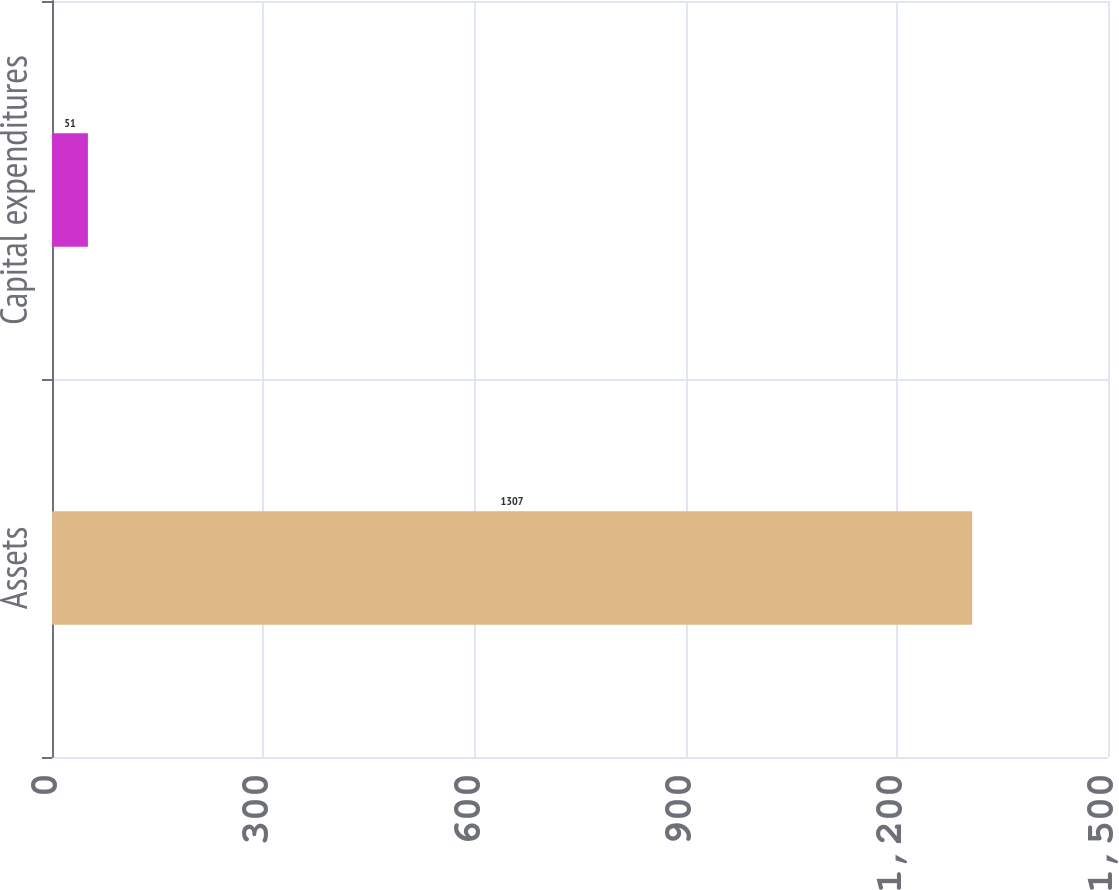Convert chart. <chart><loc_0><loc_0><loc_500><loc_500><bar_chart><fcel>Assets<fcel>Capital expenditures<nl><fcel>1307<fcel>51<nl></chart> 